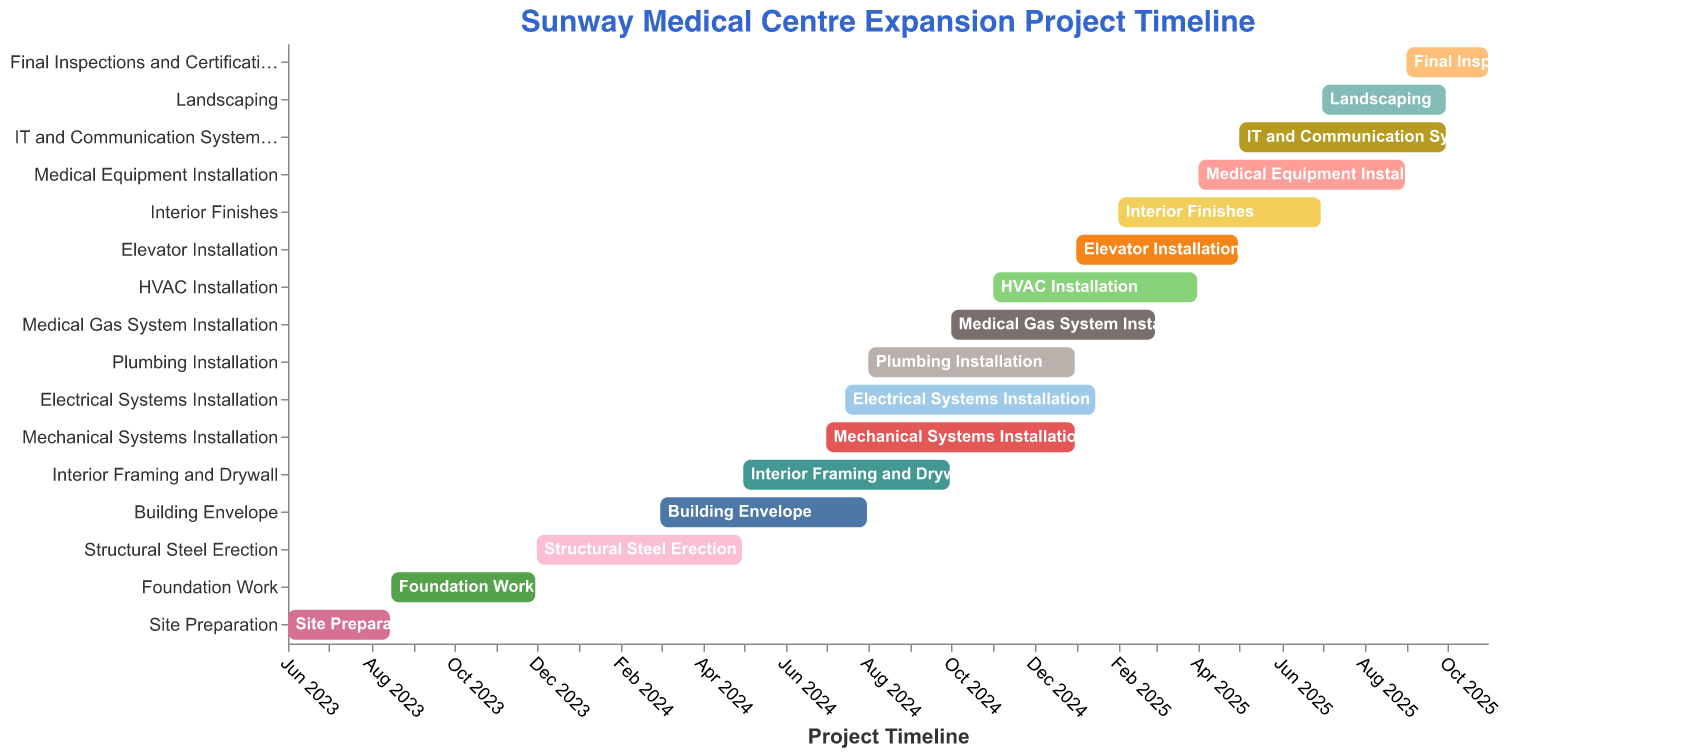What is the title of the Gantt chart? The title of the Gantt chart is displayed at the top of the figure. It reads "Sunway Medical Centre Expansion Project Timeline".
Answer: Sunway Medical Centre Expansion Project Timeline How long is the "Site Preparation" phase? The "Site Preparation" phase starts on June 1, 2023, and ends on August 15, 2023. Counting the days from June 1 to August 15 gives a total of 76 days.
Answer: 76 days Which task starts immediately after "Foundation Work"? According to the timeline, "Foundation Work" ends on November 30, 2023. The next task starting right after is "Structural Steel Erection", which begins on December 1, 2023.
Answer: Structural Steel Erection Which tasks overlap with "Building Envelope"? "Building Envelope" starts in March 2024 and ends in July 2024. The overlapping tasks are "Structural Steel Erection", "Interior Framing and Drywall", and the beginning of "Mechanical Systems Installation", "Electrical Systems Installation", and "Plumbing Installation".
Answer: Structural Steel Erection, Interior Framing and Drywall, Mechanical Systems Installation, Electrical Systems Installation, Plumbing Installation How many tasks are scheduled to be in progress during June 2025? The tasks in progress during June 2025 are "Medical Equipment Installation", "IT and Communication Systems Setup", "Interior Finishes", and "Landscaping". This is a total of 4 tasks.
Answer: 4 tasks When does the installation of "Electrical Systems" finish? The "Electrical Systems Installation" starts on July 15, 2024, and ends on January 15, 2025. So, it finishes on January 15, 2025.
Answer: January 15, 2025 Which phase has the longest duration in the project timeline? By calculating the duration for each phase, "HVAC Installation" lasts from November 1, 2024, to March 31, 2025, which is approximately 151 days making it the longest duration among all tasks.
Answer: HVAC Installation How many months does the entire project span, from "Site Preparation" to "Final Inspections and Certifications"? The project starts in June 2023 with "Site Preparation" and ends in October 2025 with "Final Inspections and Certifications". That covers a span of 29 months.
Answer: 29 months What are the last three tasks in the timeline? The last three tasks in the timeline are "IT and Communication Systems Setup", "Landscaping", and "Final Inspections and Certifications".
Answer: IT and Communication Systems Setup, Landscaping, Final Inspections and Certifications Are there any tasks that start and end within the same month? No tasks start and end within the same calendar month according to the timeline. Each task spans across at least two months.
Answer: No 